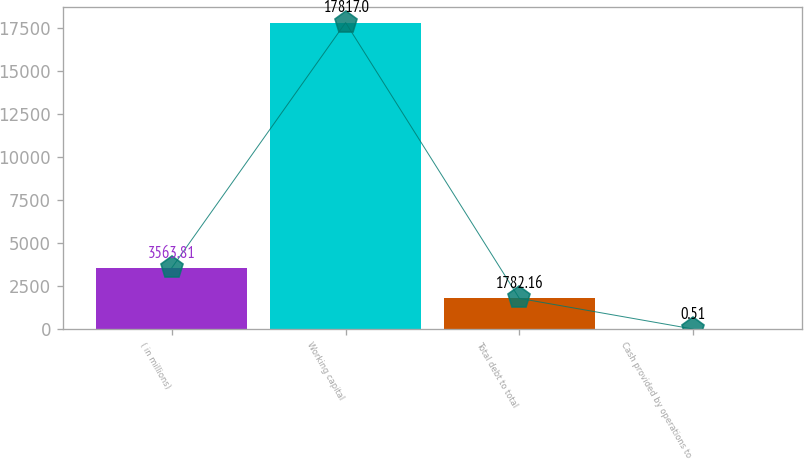Convert chart. <chart><loc_0><loc_0><loc_500><loc_500><bar_chart><fcel>( in millions)<fcel>Working capital<fcel>Total debt to total<fcel>Cash provided by operations to<nl><fcel>3563.81<fcel>17817<fcel>1782.16<fcel>0.51<nl></chart> 